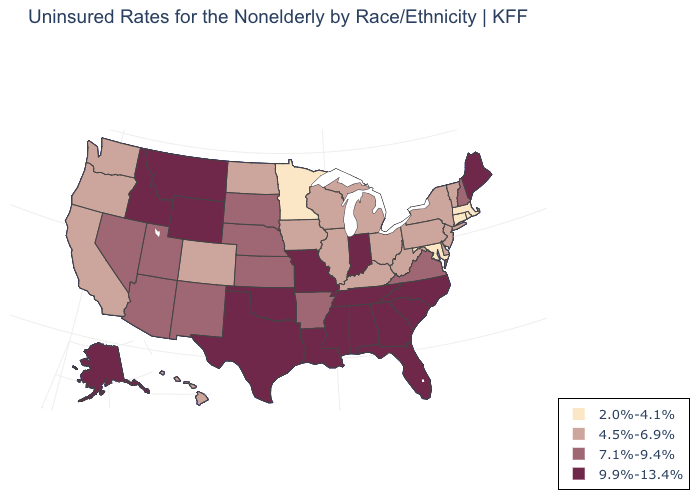Does the map have missing data?
Write a very short answer. No. What is the value of Rhode Island?
Give a very brief answer. 2.0%-4.1%. Among the states that border Ohio , which have the highest value?
Write a very short answer. Indiana. Does Arkansas have the highest value in the South?
Be succinct. No. Name the states that have a value in the range 2.0%-4.1%?
Keep it brief. Connecticut, Maryland, Massachusetts, Minnesota, Rhode Island. Does Connecticut have the same value as Maryland?
Give a very brief answer. Yes. What is the value of California?
Short answer required. 4.5%-6.9%. What is the highest value in states that border Oregon?
Be succinct. 9.9%-13.4%. What is the value of Alabama?
Write a very short answer. 9.9%-13.4%. Name the states that have a value in the range 9.9%-13.4%?
Be succinct. Alabama, Alaska, Florida, Georgia, Idaho, Indiana, Louisiana, Maine, Mississippi, Missouri, Montana, North Carolina, Oklahoma, South Carolina, Tennessee, Texas, Wyoming. What is the lowest value in states that border Tennessee?
Be succinct. 4.5%-6.9%. Which states have the highest value in the USA?
Give a very brief answer. Alabama, Alaska, Florida, Georgia, Idaho, Indiana, Louisiana, Maine, Mississippi, Missouri, Montana, North Carolina, Oklahoma, South Carolina, Tennessee, Texas, Wyoming. How many symbols are there in the legend?
Short answer required. 4. Name the states that have a value in the range 2.0%-4.1%?
Give a very brief answer. Connecticut, Maryland, Massachusetts, Minnesota, Rhode Island. What is the value of Nevada?
Quick response, please. 7.1%-9.4%. 